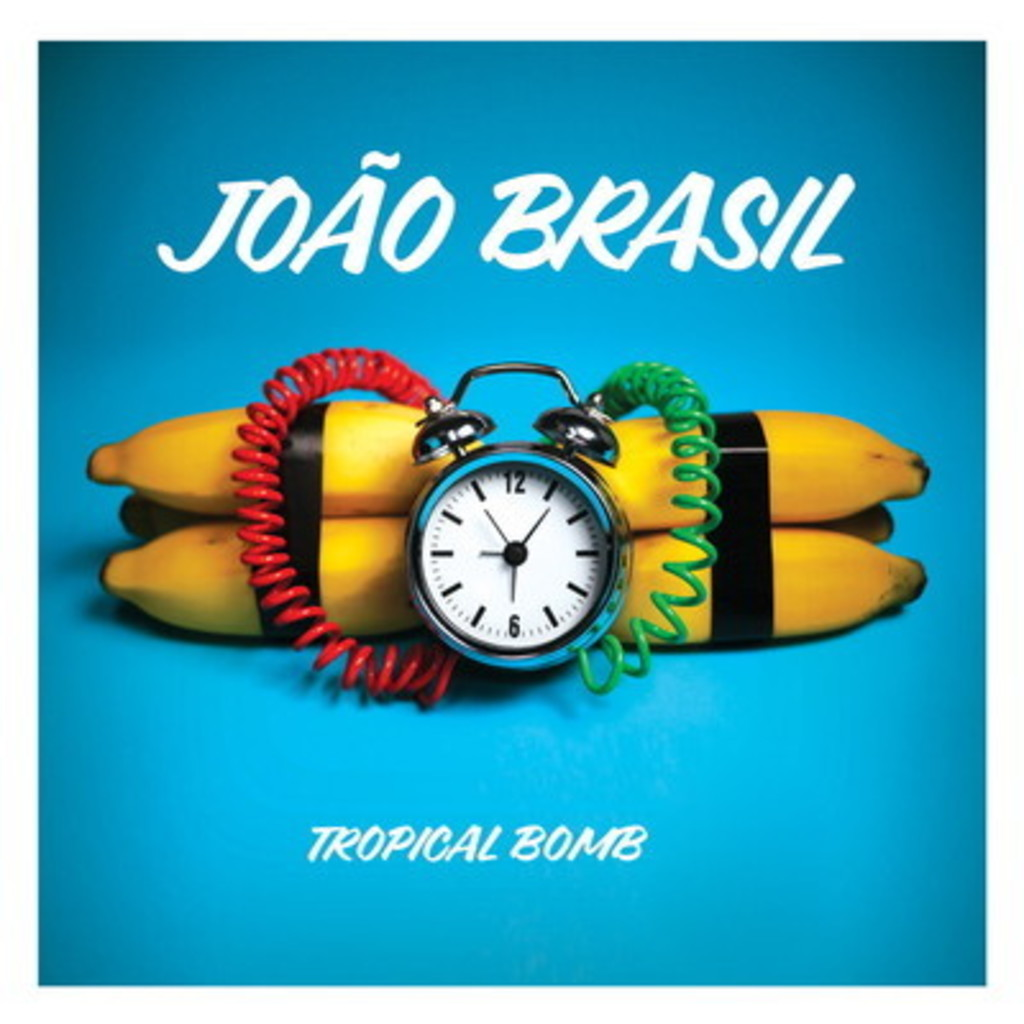What might the clock set at 6 o'clock symbolize in relation to the album's theme? The clock set at 6 o'clock could signify a moment of explosion or impact, aligning with the 'bomb' in 'Tropical Bomb'. This timing might indicate a pivotal moment in the music or a thematic turning point in the album, suggesting energy, awakening, or a burst of activity metaphorically represented through the daily time when many people conclude their work or start their evening. 